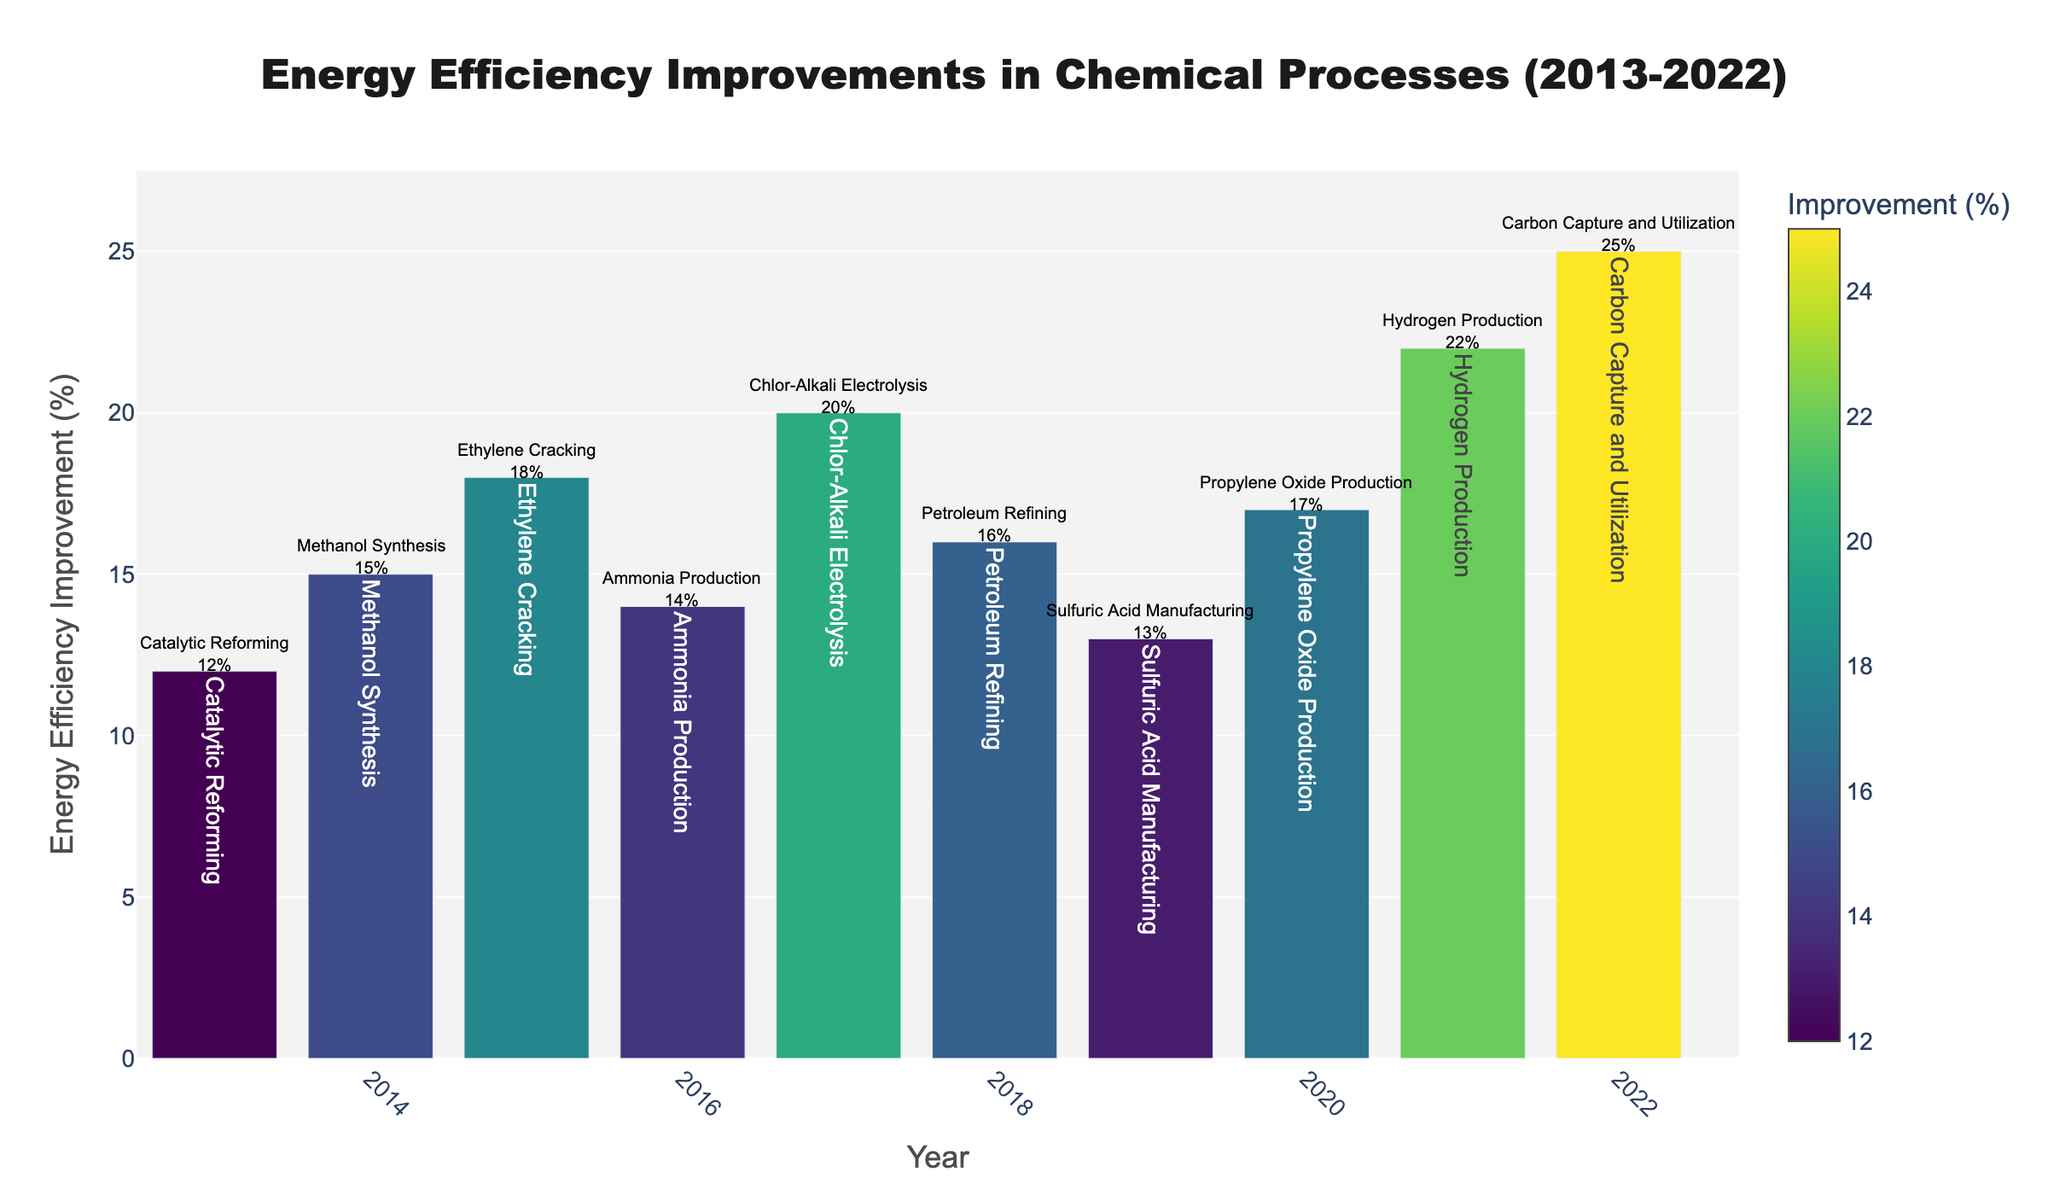What's the average energy efficiency improvement across all years? To find the average, sum all the energy efficiency improvements and divide by the number of years. (12+15+18+14+20+16+13+17+22+25) = 172, so the average is 172/10 = 17.2
Answer: 17.2 Which year had the highest energy efficiency improvement? The tallest bar represents the highest energy efficiency improvement. The year 2022 has the highest improvement at 25%.
Answer: 2022 What is the difference in energy efficiency improvement between the year 2022 and 2013? The improvement in 2022 is 25% and in 2013 is 12%. The difference is 25 - 12 = 13%.
Answer: 13% Which process in 2017 had the highest energy efficiency improvement? Look for the highest bar in 2017. The Chlor-Alkali Electrolysis process had the highest improvement at 20%.
Answer: Chlor-Alkali Electrolysis Is the energy efficiency improvement for Ammonia Production greater or lesser than Petroleum Refining? Ammonia Production in 2016 has an improvement of 14% and Petroleum Refining in 2018 has 16%. Since 14% is less than 16%, Ammonia Production is lesser.
Answer: lesser Which processes experienced more than 20% improvement in any year? Based on the data, Hydrogen Production in 2021 (22%) and Carbon Capture and Utilization in 2022 (25%) experienced more than 20% improvement.
Answer: Hydrogen Production, Carbon Capture and Utilization How many years show an energy efficiency improvement of 18% or more? Count the bars with heights of 18% or more. The years 2015, 2017, 2020, 2021, and 2022 meet this criterion, totaling five years.
Answer: 5 What's the median value of energy efficiency improvements across the decade? Sort the improvements: 12, 13, 14, 15, 16, 17, 18, 20, 22, 25. The median (middle value) for 10 numbers is the average of the 5th and 6th values: (16+17)/2 = 16.5
Answer: 16.5 Which process had a higher energy efficiency improvement, Methanol Synthesis or Propylene Oxide Production? Methanol Synthesis in 2014 had an improvement of 15% and Propylene Oxide Production in 2020 had 17%. Since 17% is greater than 15%, Propylene Oxide Production had a higher improvement.
Answer: Propylene Oxide Production 